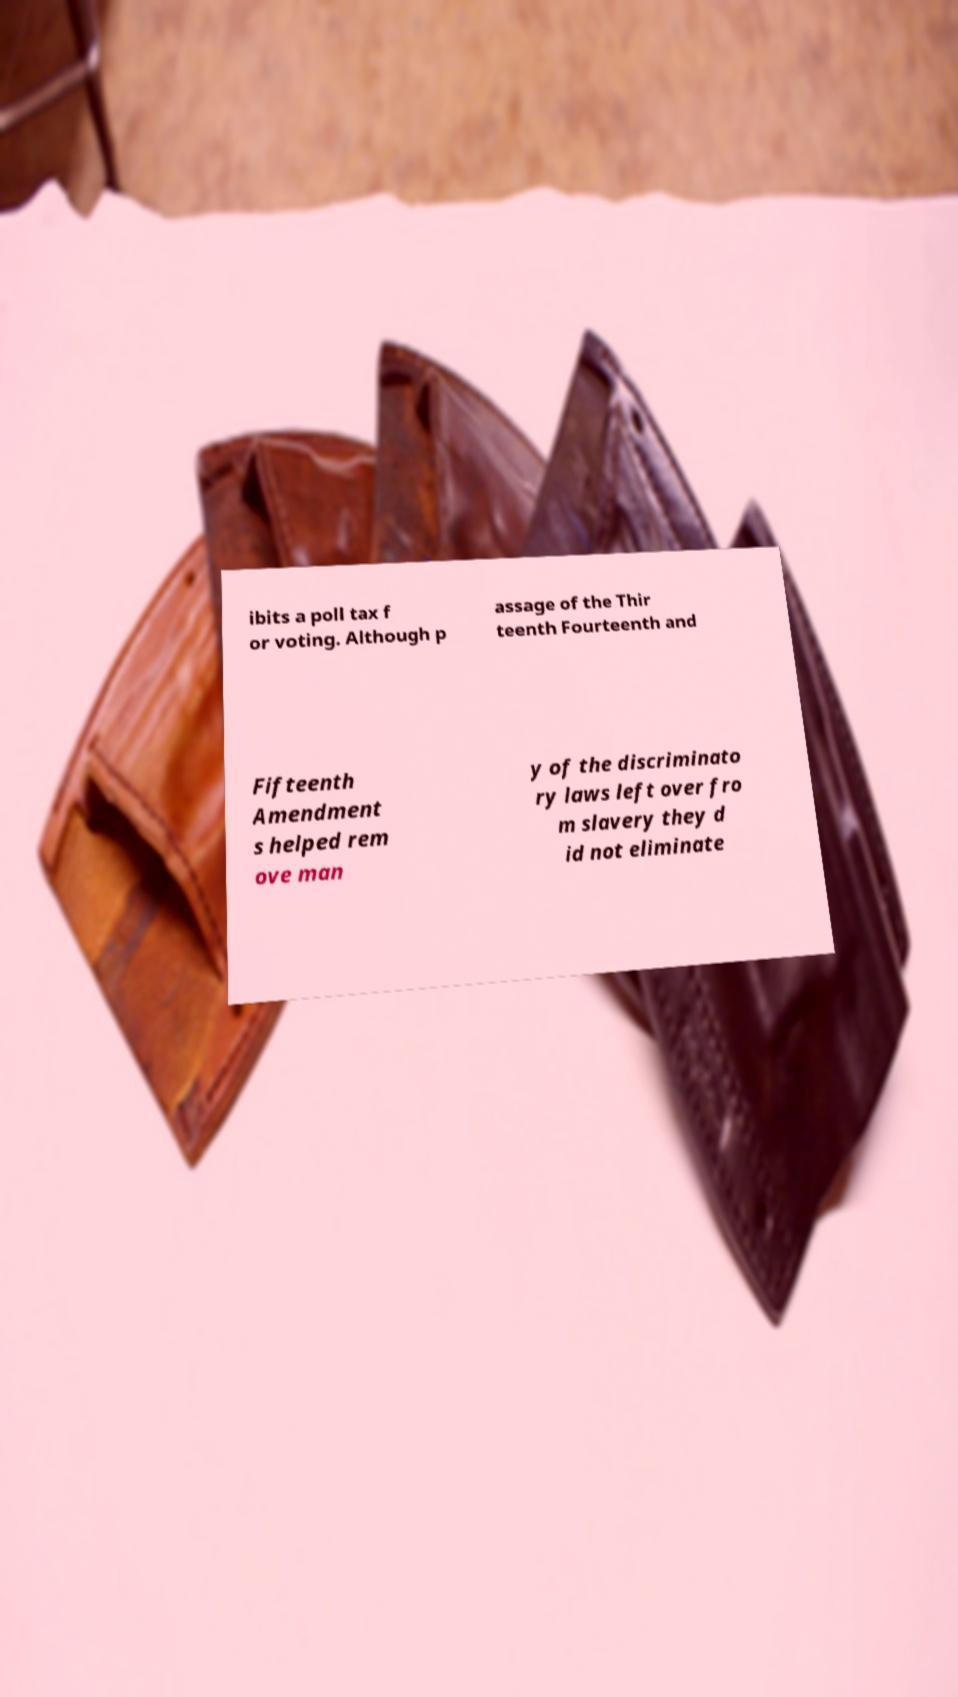Can you read and provide the text displayed in the image?This photo seems to have some interesting text. Can you extract and type it out for me? ibits a poll tax f or voting. Although p assage of the Thir teenth Fourteenth and Fifteenth Amendment s helped rem ove man y of the discriminato ry laws left over fro m slavery they d id not eliminate 